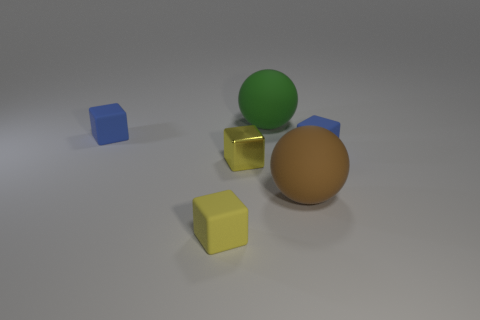What number of other things are the same shape as the yellow rubber object?
Offer a very short reply. 3. Is the color of the big object that is on the right side of the large green thing the same as the tiny matte object to the right of the large brown matte sphere?
Ensure brevity in your answer.  No. There is a yellow rubber block that is in front of the small yellow metallic block; is its size the same as the blue cube left of the green matte thing?
Your answer should be compact. Yes. Are there any other things that are the same material as the brown thing?
Ensure brevity in your answer.  Yes. What material is the big ball to the right of the large green object right of the small blue block to the left of the large green sphere made of?
Provide a succinct answer. Rubber. Do the yellow shiny object and the yellow rubber object have the same shape?
Your answer should be very brief. Yes. What is the material of the other tiny yellow thing that is the same shape as the shiny object?
Offer a terse response. Rubber. How many rubber spheres are the same color as the small metal thing?
Ensure brevity in your answer.  0. There is a ball that is made of the same material as the green object; what is its size?
Your response must be concise. Large. How many blue objects are either tiny metallic objects or tiny rubber things?
Keep it short and to the point. 2. 